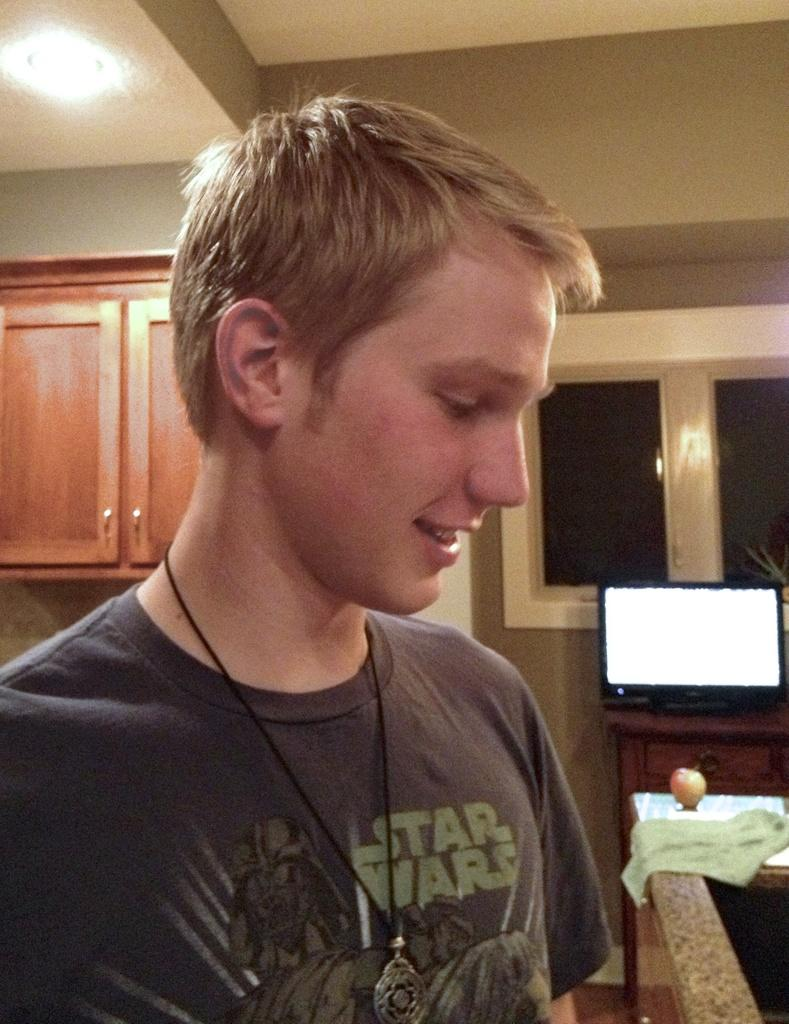Who is present in the image? There is a man in the image. What is the man's facial expression? The man is smiling. What can be seen on the table in the background? There is fruit and cloth on the table in the background. What type of furniture is visible in the background? There are cupboards in the background. What is the purpose of the window in the background? The window provides natural light and a view of the outside. What is the source of artificial light in the image? There is a light visible at the top of the image. What type of coat is the scarecrow wearing in the image? There is no scarecrow present in the image, so it is not possible to determine what type of coat it might be wearing. 